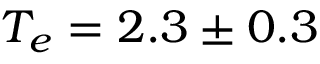<formula> <loc_0><loc_0><loc_500><loc_500>T _ { e } = 2 . 3 \pm 0 . 3</formula> 